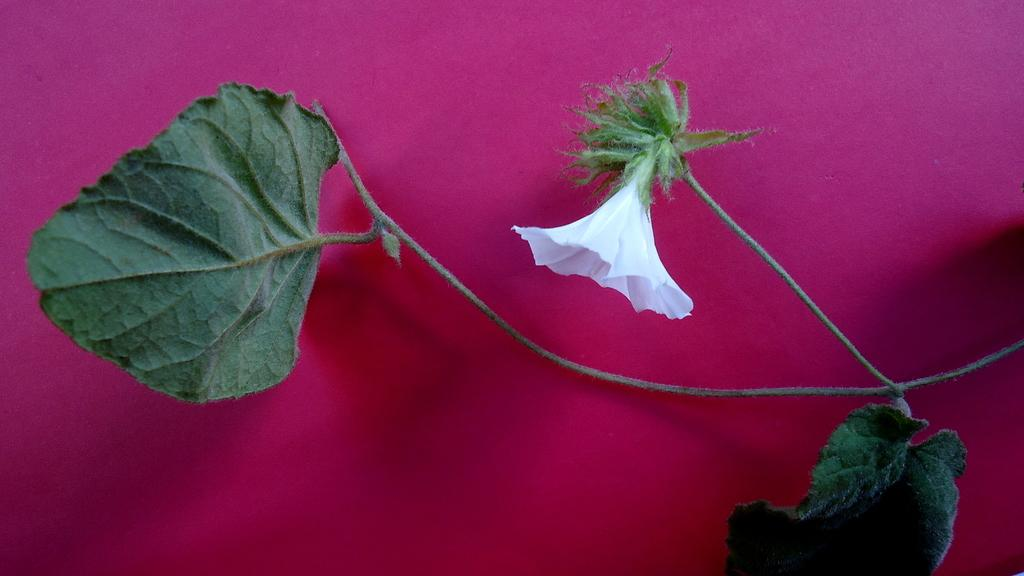What type of plant is visible on the right side of the image? There is a plant on the right side of the image. What color are the leaves of the plant? The plant has green leaves. What type of flower is present on the plant? The plant has a white flower. What color is the background of the image? The background of the image is pink in color. Can you see a hill in the background of the image? There is no hill visible in the background of the image; it has a pink background. Is there a fan attached to the plant in the image? There is no fan present in the image; it features a plant with green leaves and a white flower. 